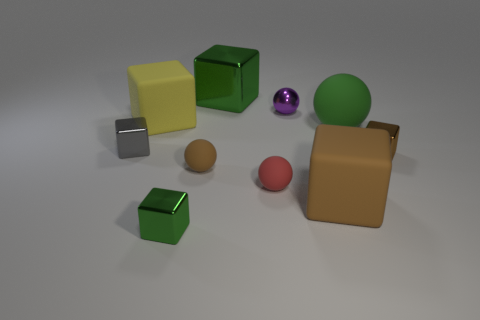Subtract all gray blocks. How many blocks are left? 5 Subtract all tiny brown cubes. How many cubes are left? 5 Subtract all yellow cubes. Subtract all cyan cylinders. How many cubes are left? 5 Subtract all blocks. How many objects are left? 4 Subtract all balls. Subtract all brown objects. How many objects are left? 3 Add 3 big brown things. How many big brown things are left? 4 Add 1 red matte spheres. How many red matte spheres exist? 2 Subtract 0 blue spheres. How many objects are left? 10 